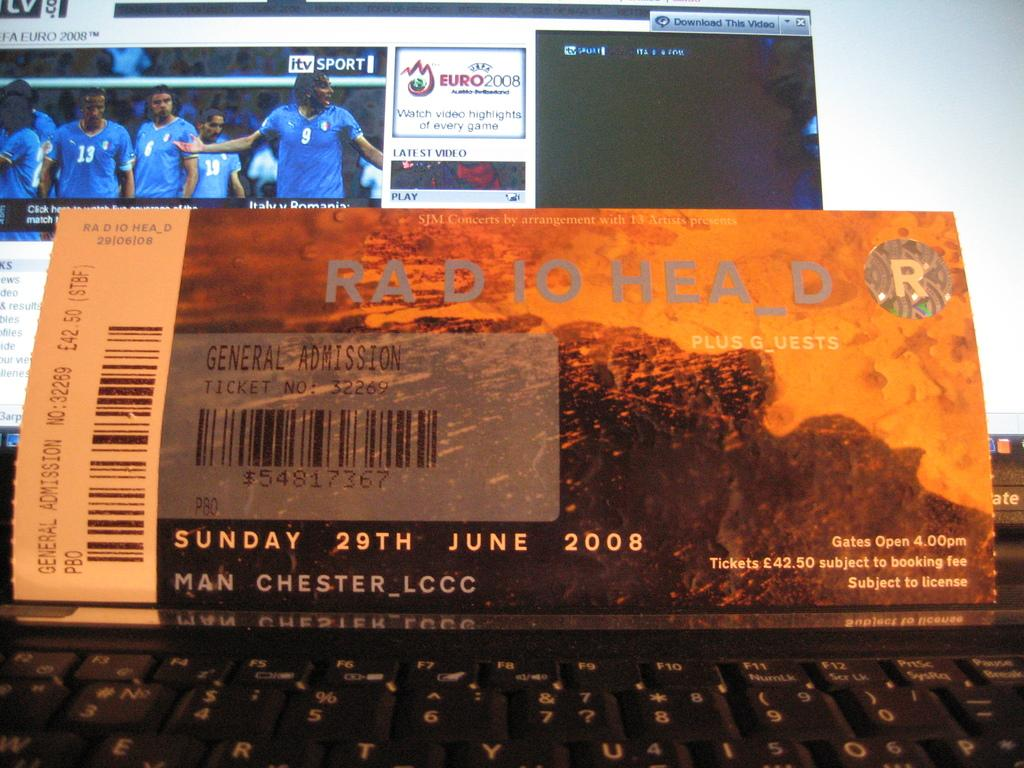<image>
Give a short and clear explanation of the subsequent image. A general admission ticket to Radiohead on June 29th 2008 sits in front of a laptop screen 